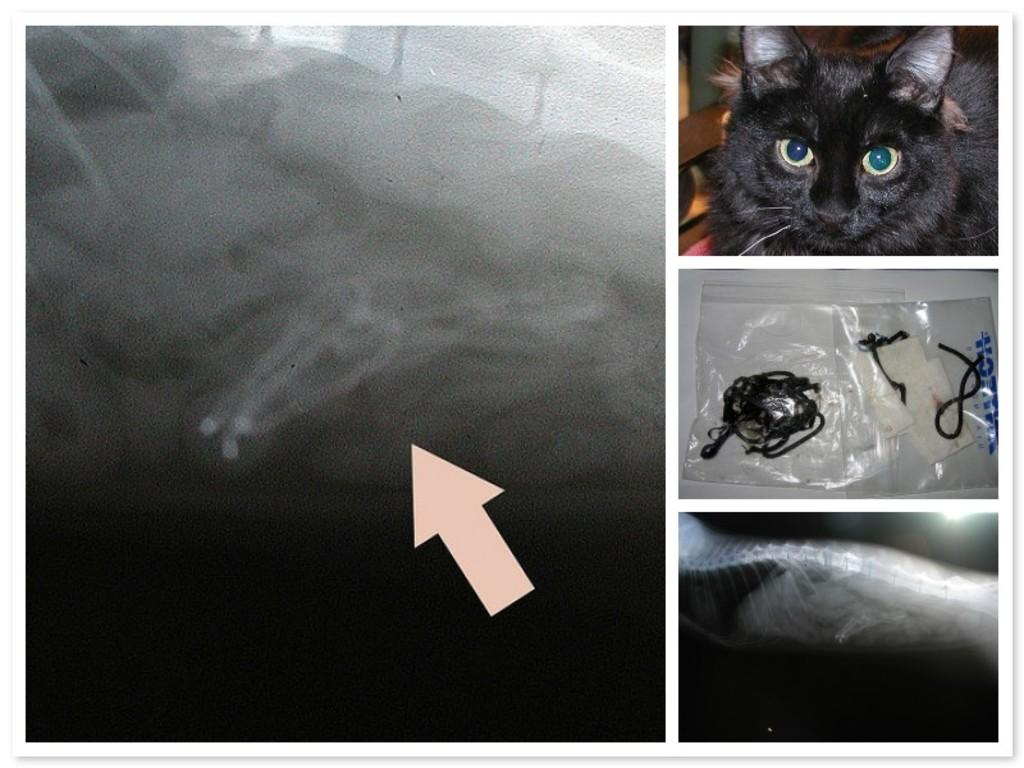What type of image is shown in the picture? The image is a photo collage. Can you describe any animals present in the image? There is a black color cat in the image. Where is the cat located in the image? The cat is on the right side of the image. What other type of image can be seen in the collage? There is an x-ray in the image. How is the x-ray positioned in the collage? The x-ray is at the down side of the image. What trick does the cat perform in the image? There is no indication of the cat performing a trick in the image. How does the spy use the x-ray in the image? There is no spy present in the image, and the x-ray is not being used for any specific purpose. 